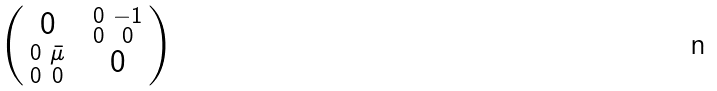<formula> <loc_0><loc_0><loc_500><loc_500>\begin{pmatrix} 0 & \begin{smallmatrix} 0 & - 1 \\ 0 & 0 \end{smallmatrix} \\ \begin{smallmatrix} 0 & \bar { \mu } \\ 0 & 0 \end{smallmatrix} & 0 \\ \end{pmatrix}</formula> 